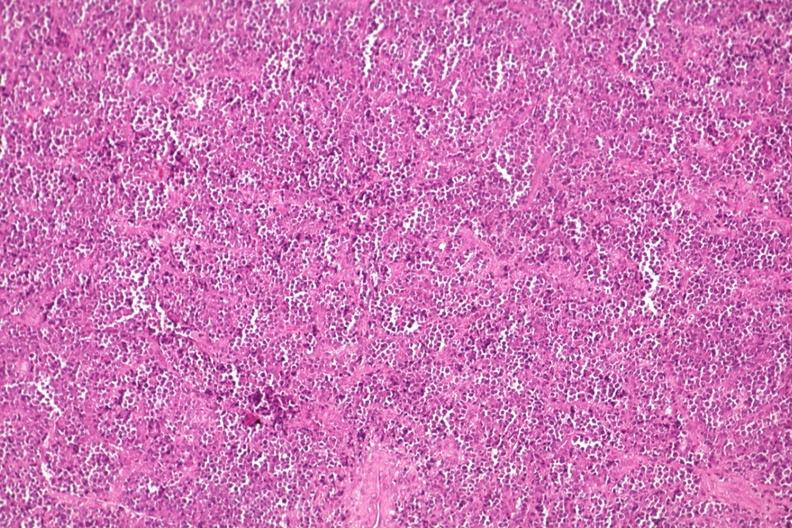s joints present?
Answer the question using a single word or phrase. Yes 